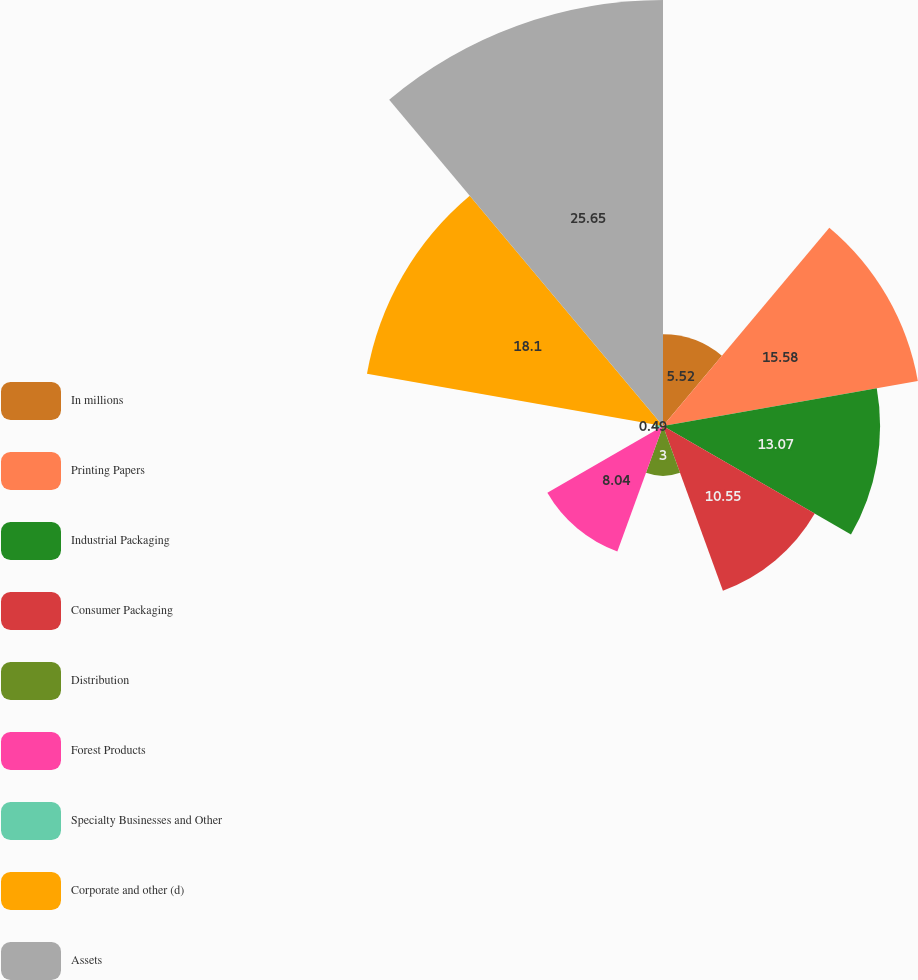Convert chart. <chart><loc_0><loc_0><loc_500><loc_500><pie_chart><fcel>In millions<fcel>Printing Papers<fcel>Industrial Packaging<fcel>Consumer Packaging<fcel>Distribution<fcel>Forest Products<fcel>Specialty Businesses and Other<fcel>Corporate and other (d)<fcel>Assets<nl><fcel>5.52%<fcel>15.58%<fcel>13.07%<fcel>10.55%<fcel>3.0%<fcel>8.04%<fcel>0.49%<fcel>18.1%<fcel>25.65%<nl></chart> 